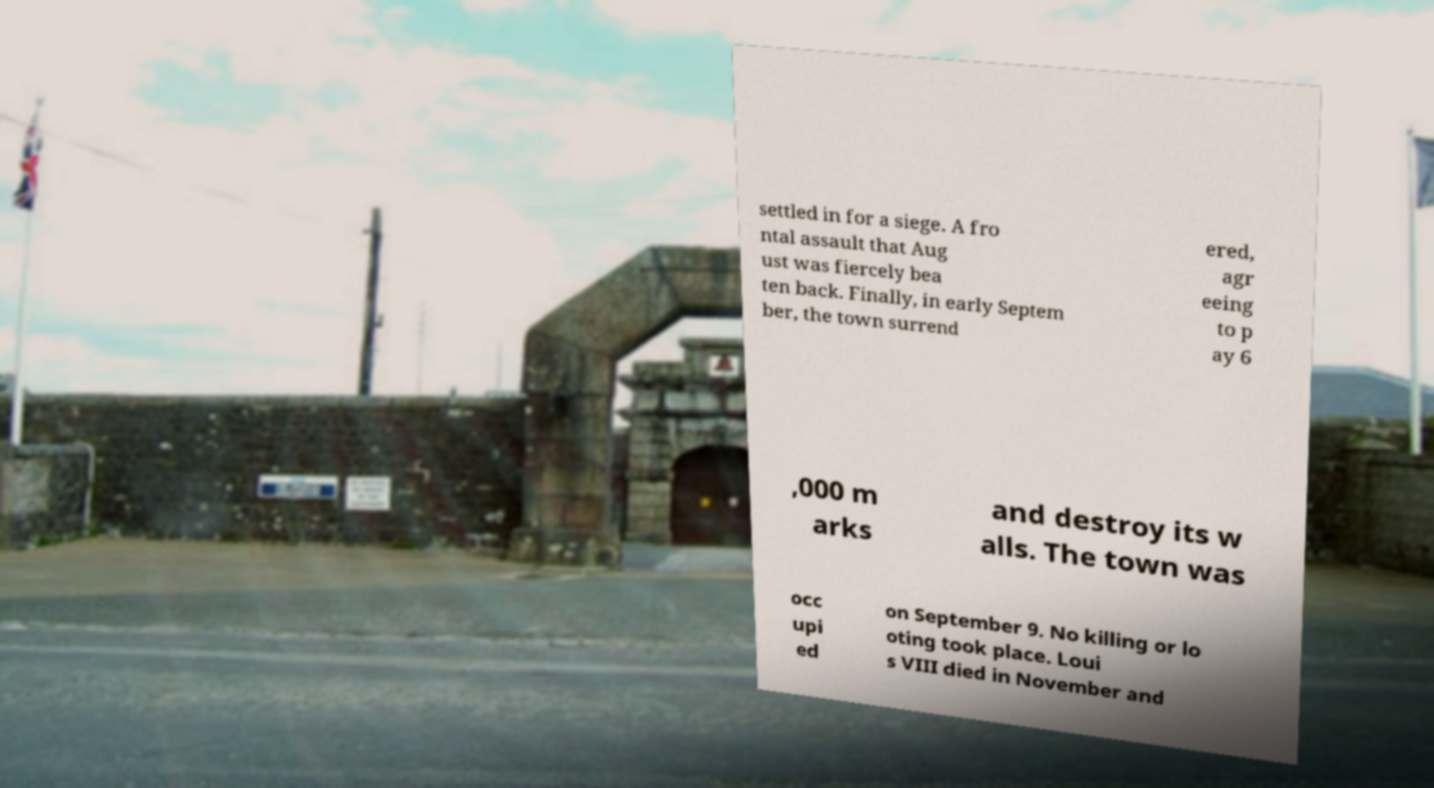I need the written content from this picture converted into text. Can you do that? settled in for a siege. A fro ntal assault that Aug ust was fiercely bea ten back. Finally, in early Septem ber, the town surrend ered, agr eeing to p ay 6 ,000 m arks and destroy its w alls. The town was occ upi ed on September 9. No killing or lo oting took place. Loui s VIII died in November and 